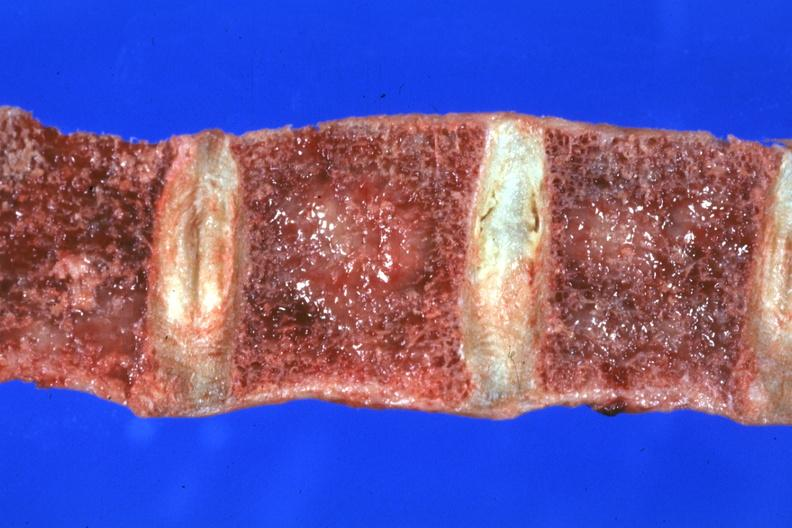s joints present?
Answer the question using a single word or phrase. Yes 